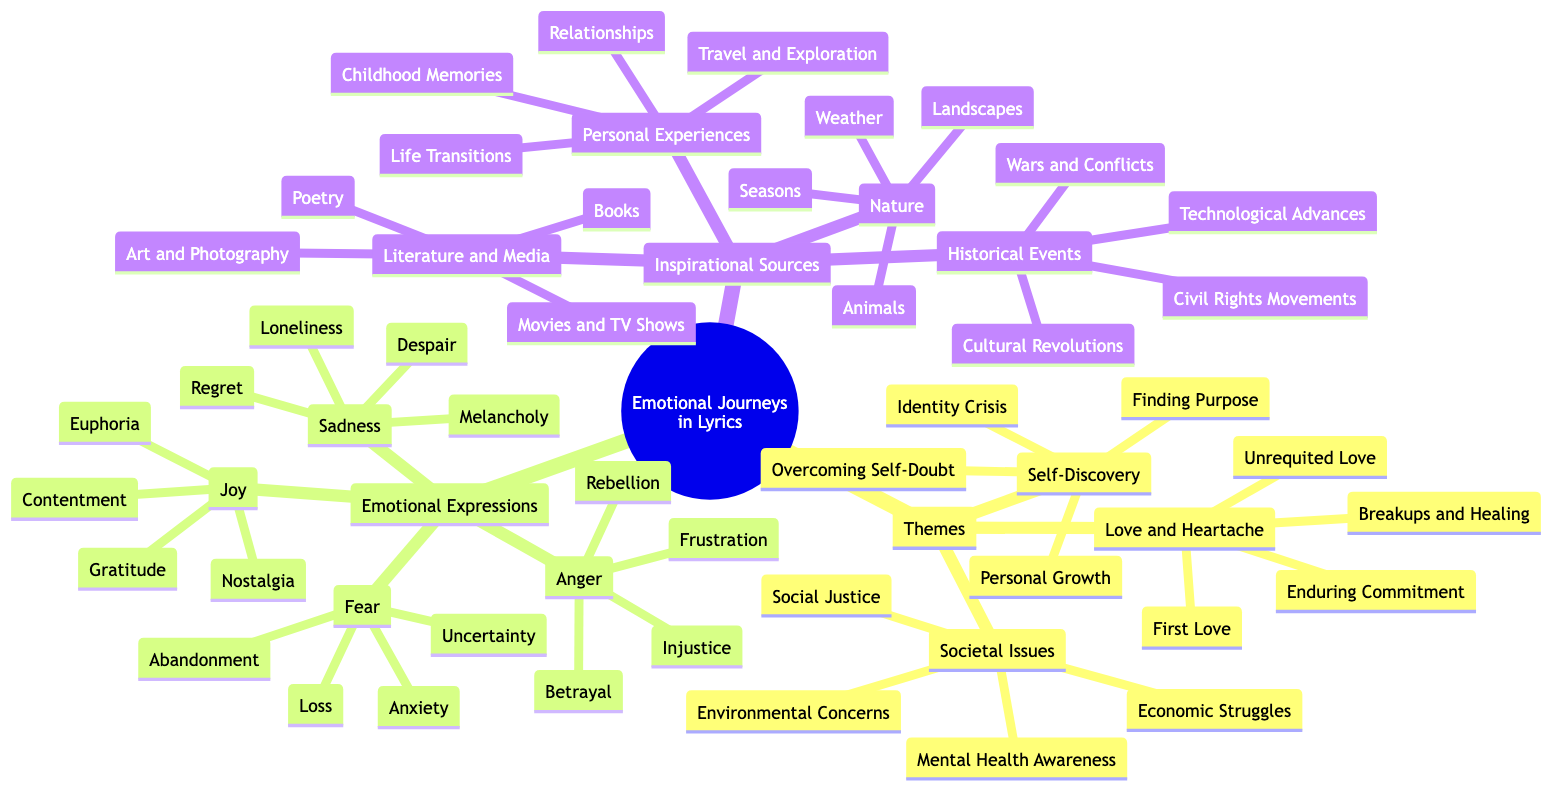What are the main themes explored in the lyrics? The main themes are "Love and Heartache," "Self-Discovery," and "Societal Issues" as they are the primary nodes under the "Themes" section of the diagram.
Answer: Love and Heartache, Self-Discovery, Societal Issues How many emotional expressions are listed in the diagram? There are four emotional expressions: "Joy," "Sadness," "Anger," and "Fear." Each represents a node under the "Emotional Expressions" section in the diagram.
Answer: 4 What type of societal issues are covered in the lyrics? The societal issues covered are "Social Justice," "Mental Health Awareness," "Environmental Concerns," and "Economic Struggles," which are listed as sub-nodes under the "Societal Issues" theme.
Answer: Social Justice, Mental Health Awareness, Environmental Concerns, Economic Struggles Which emotional expression is associated with "Despair"? "Despair" is associated with the emotional expression of "Sadness," as it is listed under the "Sadness" category in the diagram.
Answer: Sadness What are the sources of inspiration for lyrics according to the diagram? The sources of inspiration are "Personal Experiences," "Literature and Media," "Nature," and "Historical Events," indicating different areas that can evoke emotional responses for songwriting.
Answer: Personal Experiences, Literature and Media, Nature, Historical Events How many types of joy are highlighted in the diagram? There are four types of joy highlighted: "Euphoria," "Contentment," "Nostalgia," and "Gratitude," which are sub-nodes under the "Joy" emotional expression.
Answer: 4 Which emotional expression involves the theme of "Betrayal"? "Betrayal" involves the emotional expression of "Anger" as it is categorized under "Anger" in the emotional expression section of the diagram.
Answer: Anger What specific aspects of self-discovery are mentioned in the lyrics? The aspects of self-discovery mentioned are "Personal Growth," "Identity Crisis," "Finding Purpose," and "Overcoming Self-Doubt," which are all sub-nodes of the "Self-Discovery" theme.
Answer: Personal Growth, Identity Crisis, Finding Purpose, Overcoming Self-Doubt 